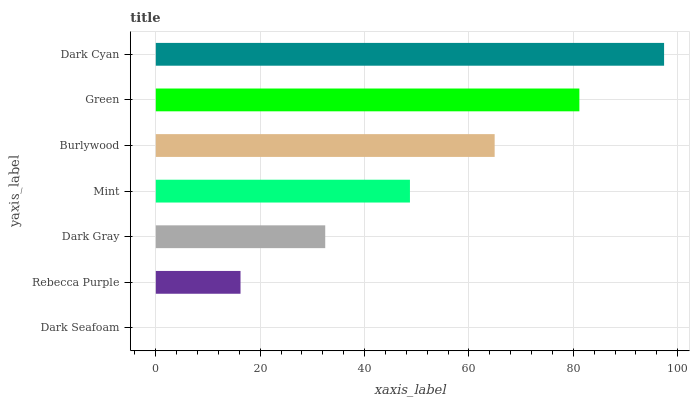Is Dark Seafoam the minimum?
Answer yes or no. Yes. Is Dark Cyan the maximum?
Answer yes or no. Yes. Is Rebecca Purple the minimum?
Answer yes or no. No. Is Rebecca Purple the maximum?
Answer yes or no. No. Is Rebecca Purple greater than Dark Seafoam?
Answer yes or no. Yes. Is Dark Seafoam less than Rebecca Purple?
Answer yes or no. Yes. Is Dark Seafoam greater than Rebecca Purple?
Answer yes or no. No. Is Rebecca Purple less than Dark Seafoam?
Answer yes or no. No. Is Mint the high median?
Answer yes or no. Yes. Is Mint the low median?
Answer yes or no. Yes. Is Rebecca Purple the high median?
Answer yes or no. No. Is Dark Seafoam the low median?
Answer yes or no. No. 